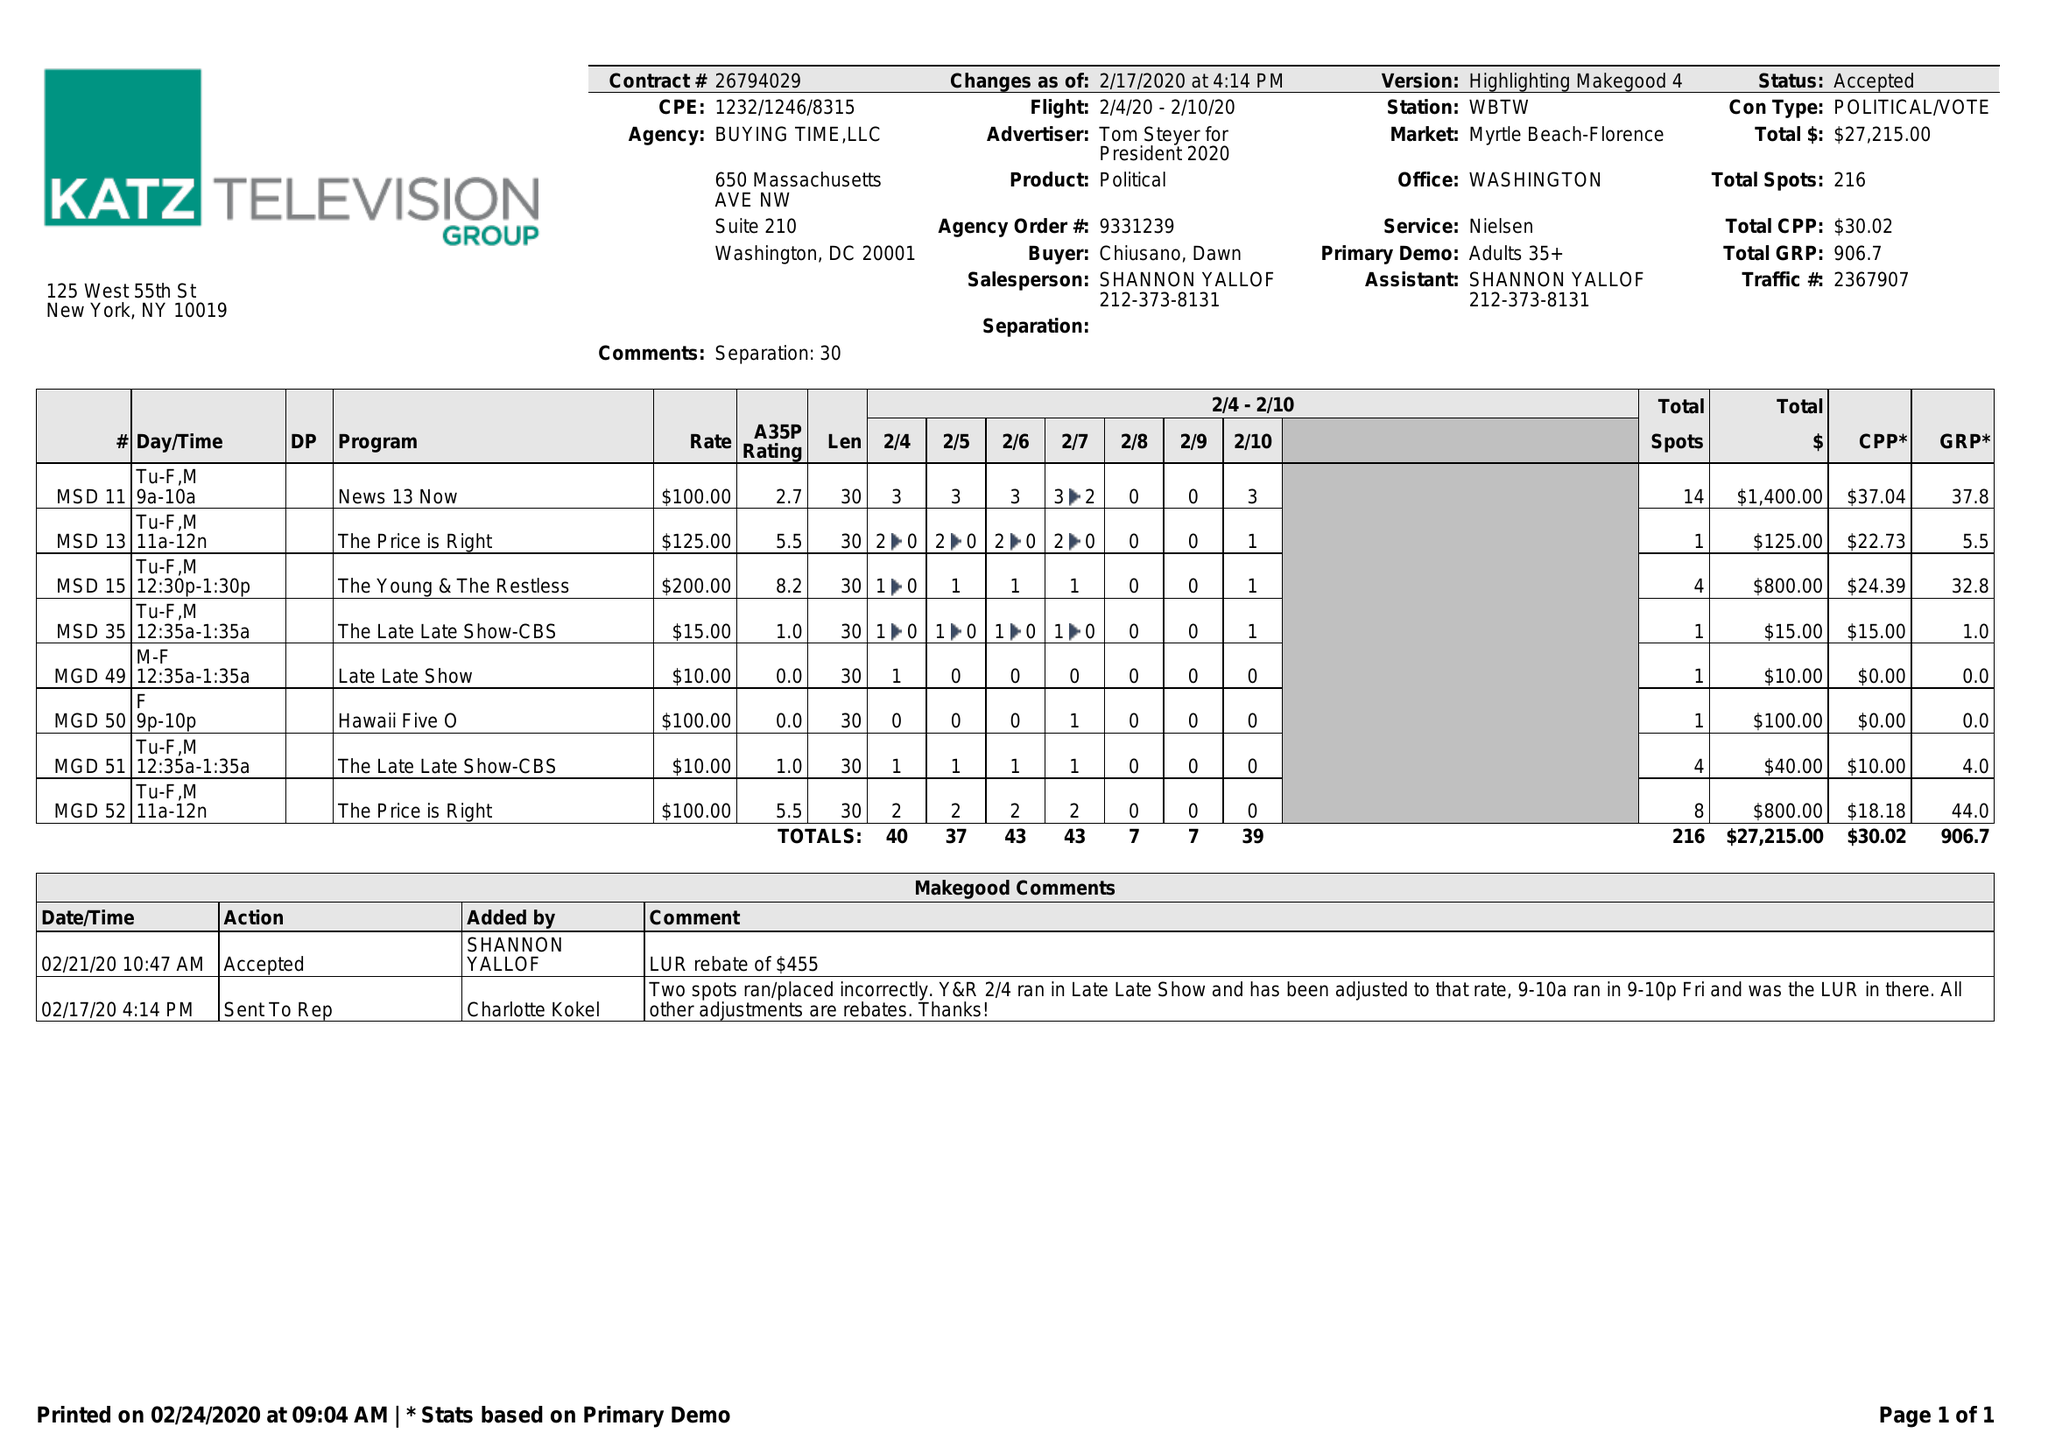What is the value for the flight_from?
Answer the question using a single word or phrase. 02/04/20 